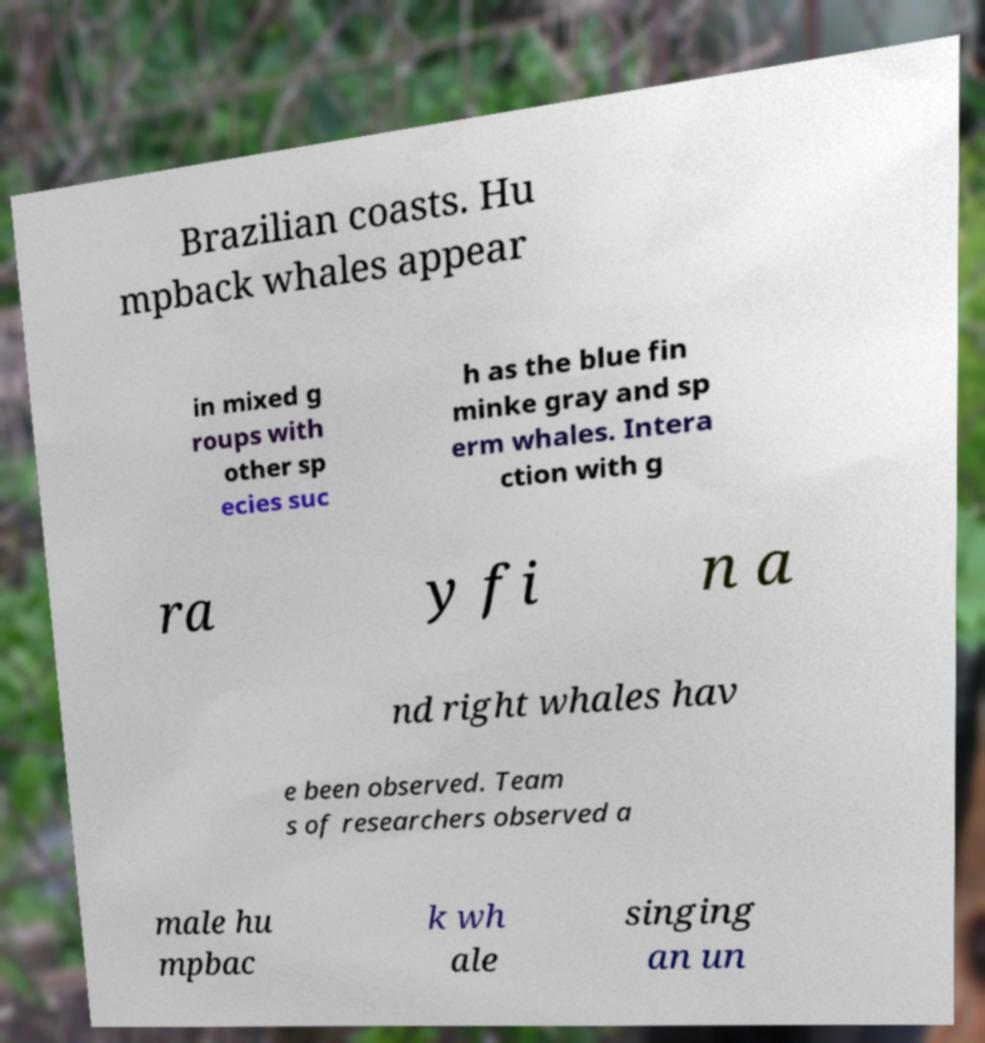Please identify and transcribe the text found in this image. Brazilian coasts. Hu mpback whales appear in mixed g roups with other sp ecies suc h as the blue fin minke gray and sp erm whales. Intera ction with g ra y fi n a nd right whales hav e been observed. Team s of researchers observed a male hu mpbac k wh ale singing an un 